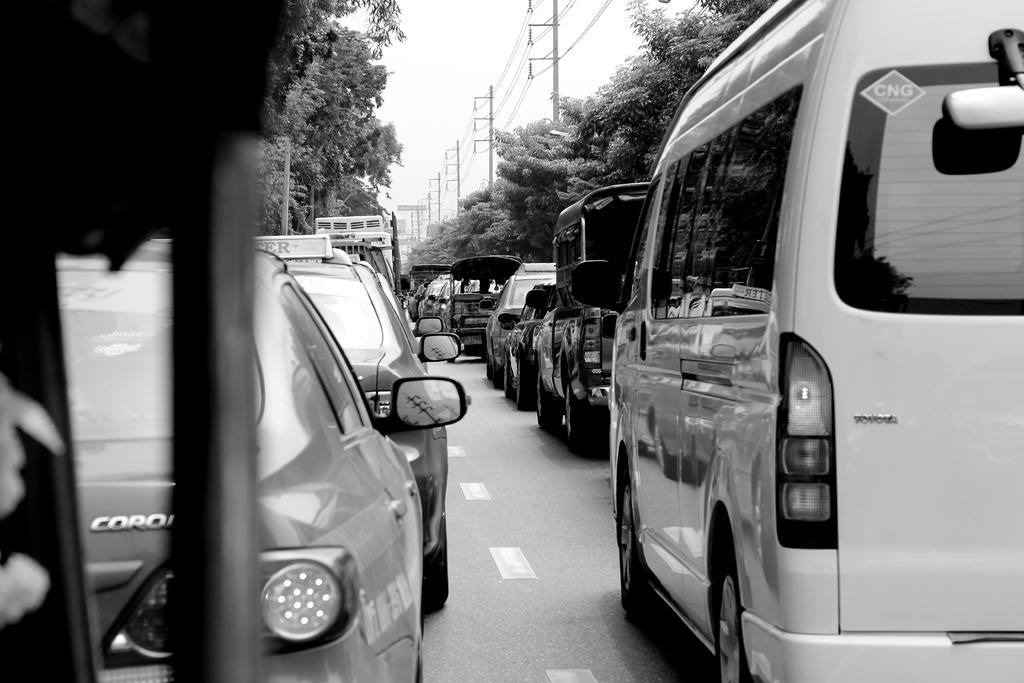What can be seen on the right side of the image? There are cars in series on the right side of the image. What can be seen on the left side of the image? There are cars in series on the left side of the image. What is visible at the top side of the image? There are trees and poles at the top side of the image. Can you hear a pig whistling in the image? There is no pig or whistling present in the image. 